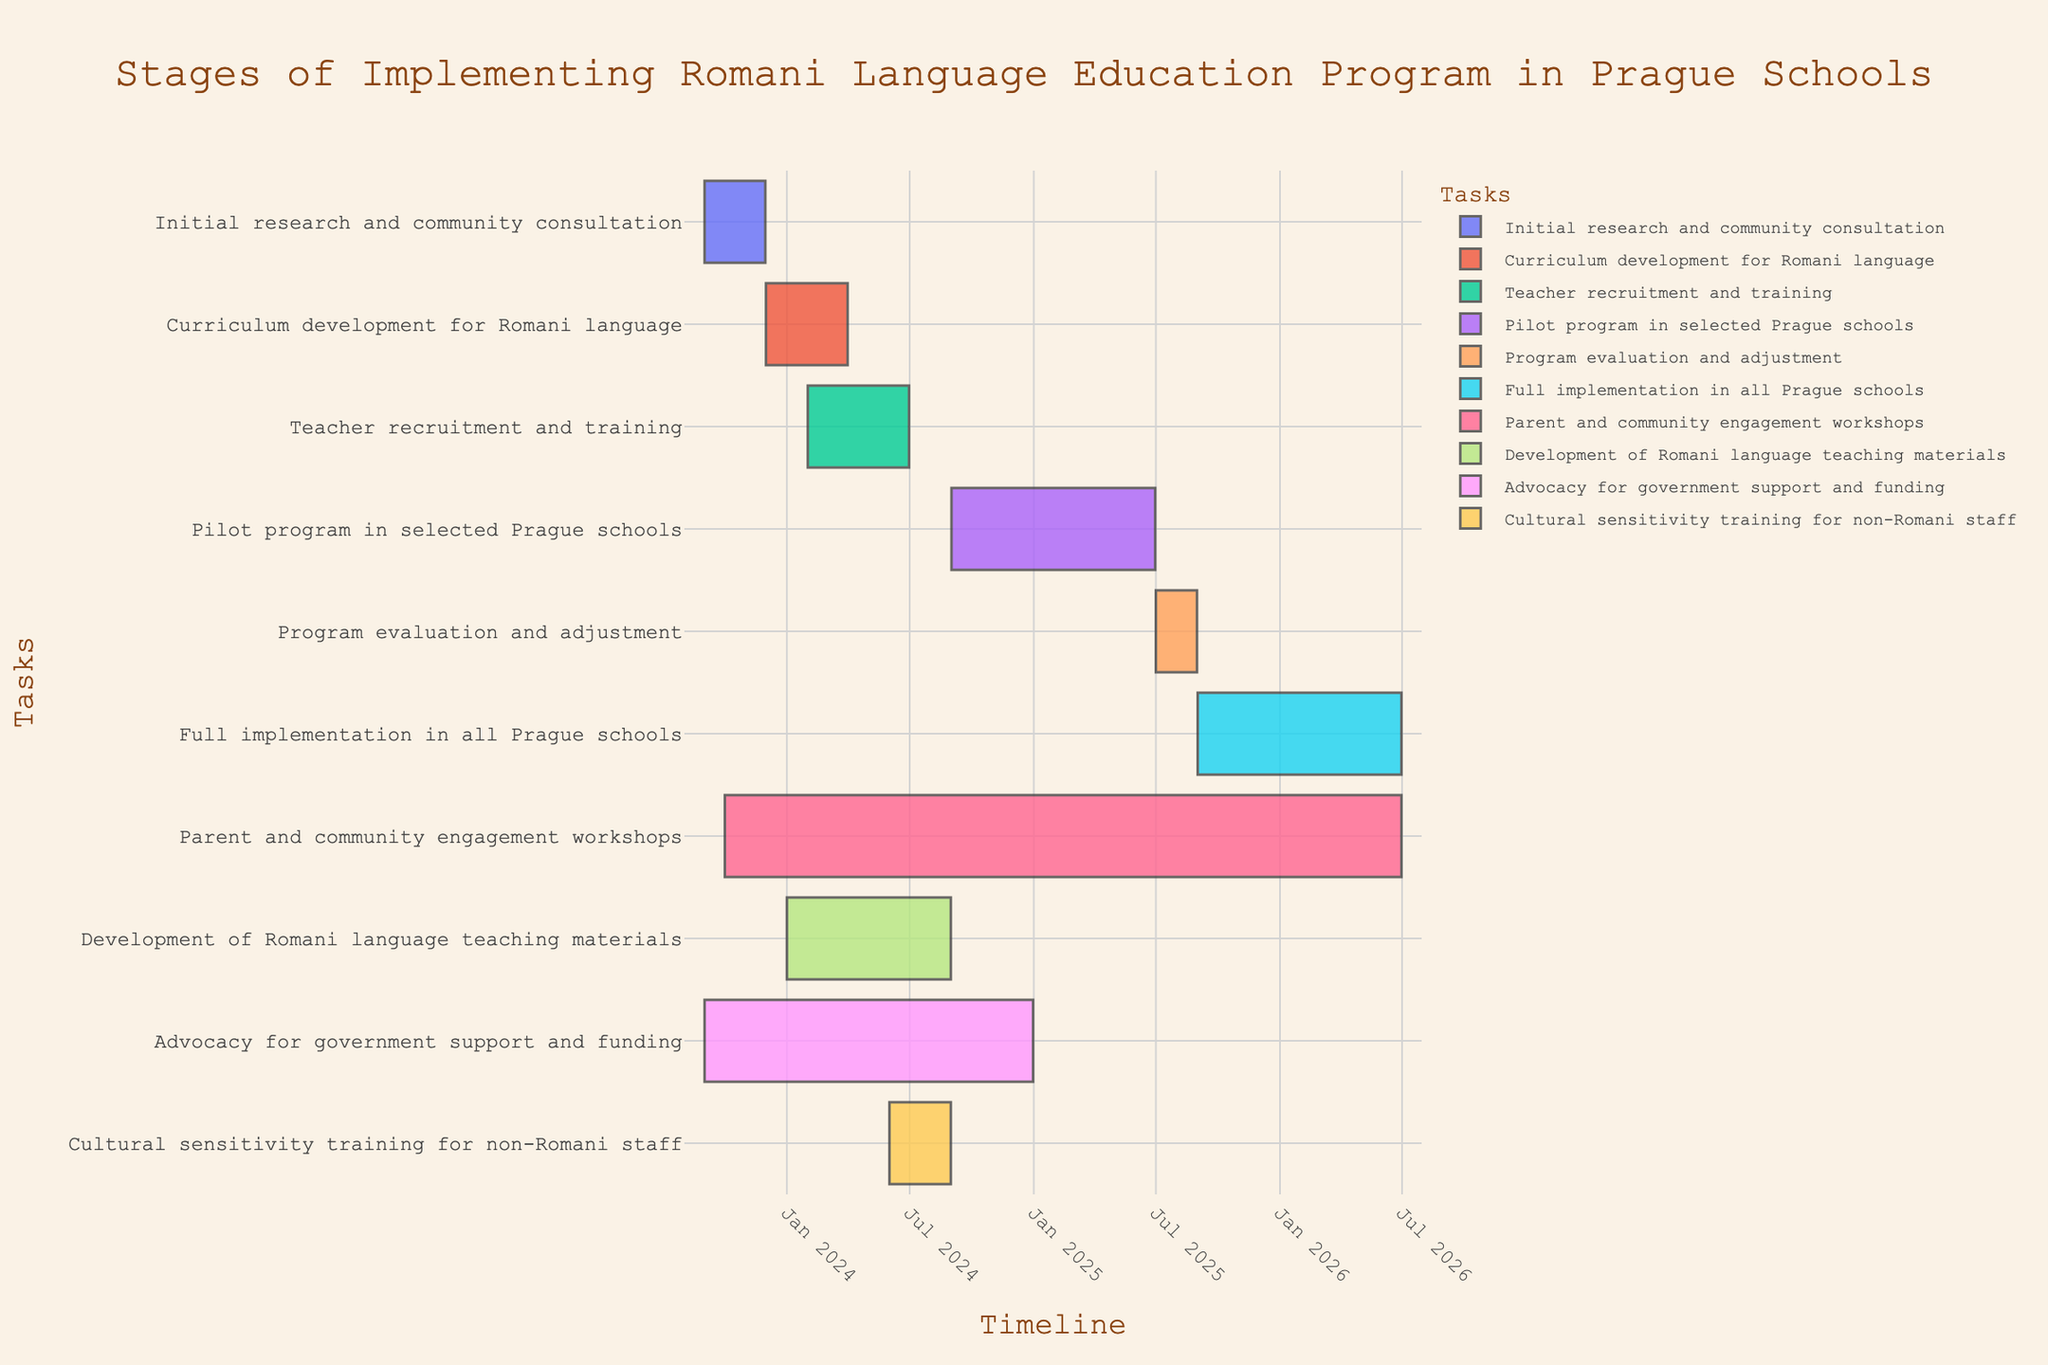What is the title of the Gantt Chart? The title is usually provided at the top of the chart. In this case, the title is "Stages of Implementing Romani Language Education Program in Prague Schools."
Answer: Stages of Implementing Romani Language Education Program in Prague Schools How many tasks are listed in the Gantt Chart? By counting the number of unique tasks listed on the y-axis of the chart, you can determine the total number of tasks.
Answer: 10 What is the start date of the initial research and community consultation task? Look for the "Initial research and community consultation" task on the y-axis and check its starting point on the x-axis.
Answer: 2023-09-01 Which task has the longest duration? By comparing the lengths (duration) of all the tasks on the Gantt Chart, you can identify which one spans the longest period.
Answer: Parent and community engagement workshops Which two tasks overlap in time during the entire month of July 2024? Identify the tasks with timelines that intersect for the duration of July 2024. Both tasks must span across this month to be considered overlapping.
Answer: Teacher recruitment and training, Development of Romani language teaching materials What is the end date of the full implementation in all Prague schools? Locate the "Full implementation in all Prague schools" task and check its ending point on the x-axis.
Answer: 2026-06-30 Which task begins immediately after the initial research and community consultation ends? Find the ending date of the "Initial research and community consultation" task and determine which task starts right after this date.
Answer: Curriculum development for Romani language Does the task of advocacy for government support and funding overlap with any part of the teacher recruitment and training task? Compare the timeline of "Advocacy for government support and funding" and "Teacher recruitment and training" to see if their timeframes intersect at any point.
Answer: Yes How many tasks are scheduled to start in September 2023? Check the start dates of all the tasks and count how many tasks begin in September 2023.
Answer: 2 Which task is entirely contained within the year 2025? Identify which task starts and ends within the calendar year 2025 by looking at its timeline on the x-axis.
Answer: Program evaluation and adjustment 